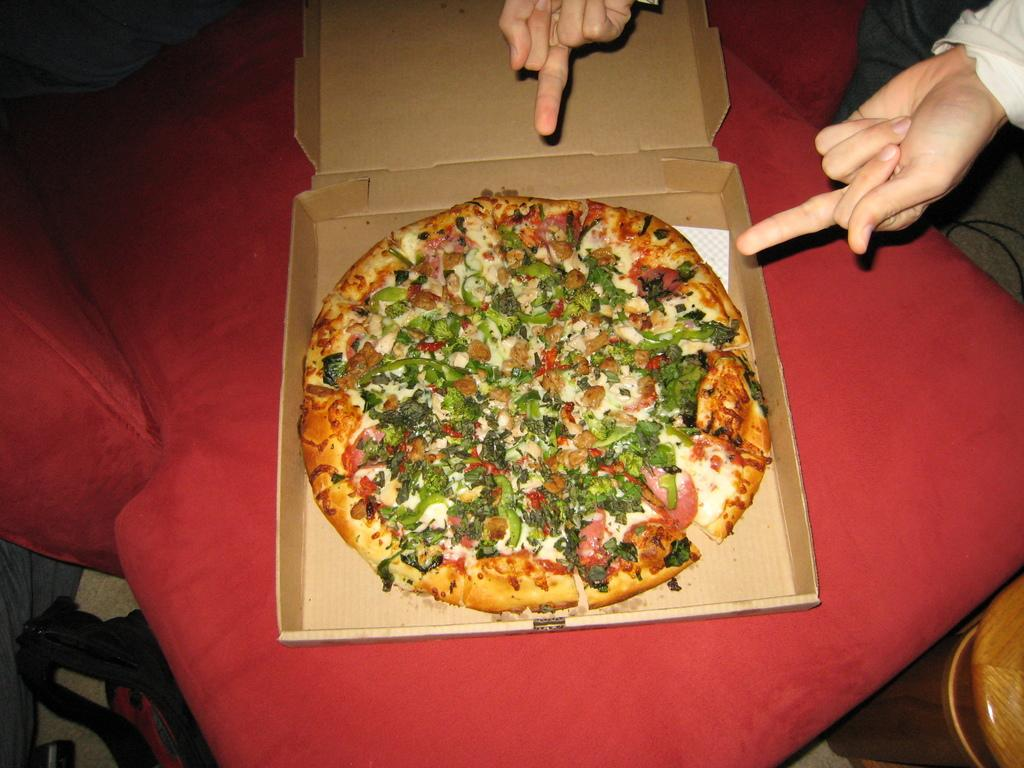What type of food is visible in the image? There is a pizza in a box in the image. Where is the pizza located? The pizza is placed on a sofa. Can you describe the person in the image? There is a person in the image, but no specific details about their appearance or actions are provided. What other objects can be seen in the image? There are other objects present in the image, but their specific nature is not mentioned in the provided facts. What type of straw is being used to extinguish the flame on the pizza in the image? There is no flame or straw present in the image; it features a pizza in a box placed on a sofa. 